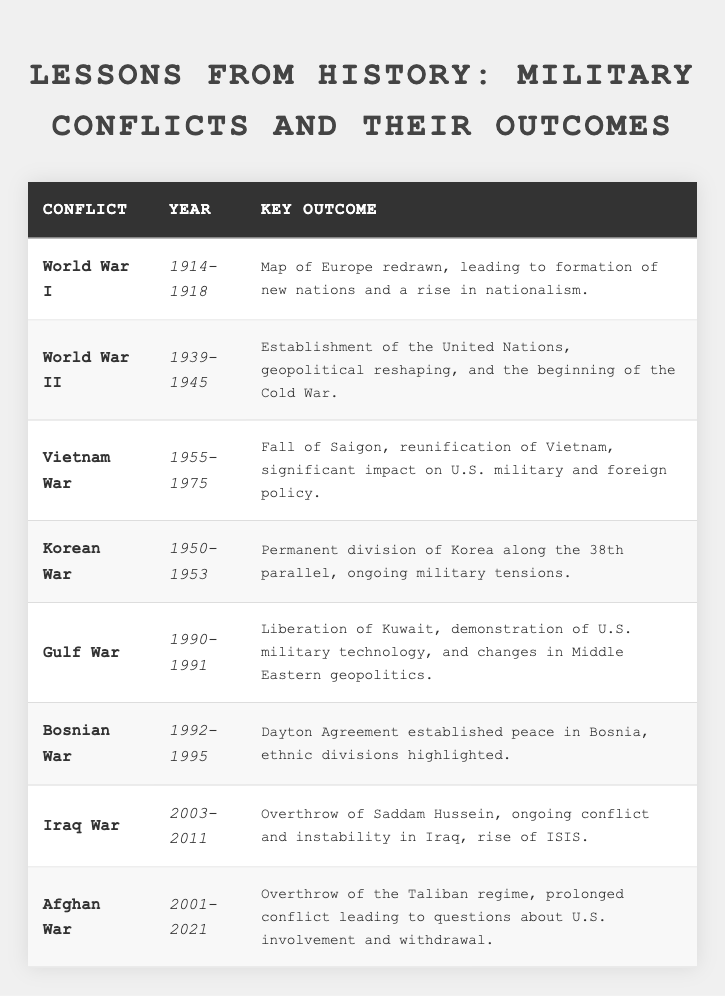What years did World War I take place? The table lists the year range for World War I as 1914-1918 in the Year column.
Answer: 1914-1918 Which conflict resulted in the establishment of the United Nations? The table states that World War II led to the establishment of the United Nations.
Answer: World War II What was the key outcome of the Gulf War? According to the Key Outcome column, the Gulf War resulted in the liberation of Kuwait, among other outcomes.
Answer: Liberation of Kuwait How many years did the Vietnam War last? The Vietnam War is listed from 1955 to 1975, so to find the duration, we subtract 1955 from 1975, which gives us 20 years.
Answer: 20 years Which conflict had a direct impact on U.S. military policy? The Vietnam War is highlighted as having a significant impact on U.S. military and foreign policy as per the Key Outcome.
Answer: Vietnam War Did the Korean War lead to the reunification of Korea? The Key Outcome for the Korean War indicates a permanent division of Korea, suggesting no reunification occurred.
Answer: No Identify the conflict that involved the overthrow of a regime. Both the Iraq War and the Afghan War involved the overthrow of regimes, specifically Saddam Hussein in Iraq and the Taliban in Afghanistan.
Answer: Iraq War and Afghan War Which conflict occurred first, the Gulf War or the Bosnian War? The Gulf War took place from 1990 to 1991, while the Bosnian War lasted from 1992 to 1995. Since 1990 is earlier than 1992, the Gulf War occurred first.
Answer: Gulf War What is the significance of the Dayton Agreement mentioned in relation to the Bosnian War? The Dayton Agreement is noted as having established peace in Bosnia, which indicates its significance in resolving conflict and restoring stability.
Answer: Established peace in Bosnia Compare the key outcomes of the Iraq War and the Afghan War. The Iraq War's outcome involved the overthrow of Saddam Hussein and ongoing conflict, while the Afghan War resulted in the overthrow of the Taliban but led to prolonged conflict and questions about U.S. involvement.
Answer: Different ongoing conflicts post-overthrow What was the overall trend in military conflicts from World War I to the Afghan War? Analyzing the table, there appears to be a trend of increased complexity and involvement of international relations, particularly seen through outcomes such as regional instability and shifts in foreign policy.
Answer: Increased complexity in international military involvement 